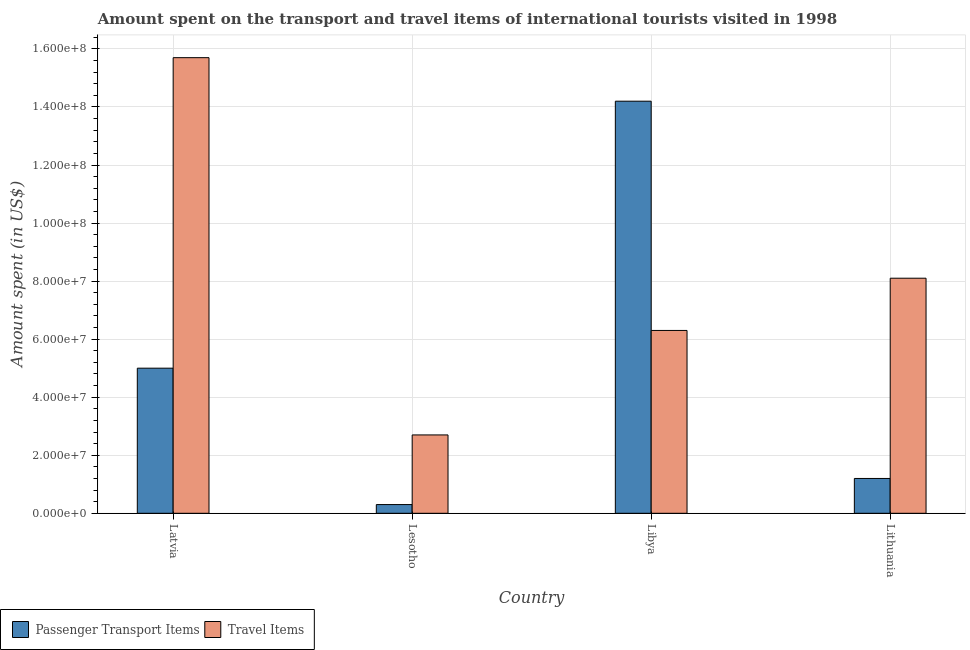How many different coloured bars are there?
Offer a terse response. 2. Are the number of bars per tick equal to the number of legend labels?
Provide a short and direct response. Yes. Are the number of bars on each tick of the X-axis equal?
Make the answer very short. Yes. What is the label of the 2nd group of bars from the left?
Your response must be concise. Lesotho. What is the amount spent on passenger transport items in Lithuania?
Your answer should be compact. 1.20e+07. Across all countries, what is the maximum amount spent on passenger transport items?
Keep it short and to the point. 1.42e+08. Across all countries, what is the minimum amount spent in travel items?
Offer a very short reply. 2.70e+07. In which country was the amount spent in travel items maximum?
Ensure brevity in your answer.  Latvia. In which country was the amount spent in travel items minimum?
Give a very brief answer. Lesotho. What is the total amount spent on passenger transport items in the graph?
Offer a terse response. 2.07e+08. What is the difference between the amount spent on passenger transport items in Latvia and that in Libya?
Your answer should be very brief. -9.20e+07. What is the difference between the amount spent in travel items in Lesotho and the amount spent on passenger transport items in Libya?
Make the answer very short. -1.15e+08. What is the average amount spent in travel items per country?
Provide a short and direct response. 8.20e+07. What is the difference between the amount spent in travel items and amount spent on passenger transport items in Lesotho?
Your answer should be compact. 2.40e+07. In how many countries, is the amount spent in travel items greater than 100000000 US$?
Provide a succinct answer. 1. What is the ratio of the amount spent on passenger transport items in Latvia to that in Lithuania?
Your answer should be very brief. 4.17. Is the amount spent on passenger transport items in Lesotho less than that in Lithuania?
Keep it short and to the point. Yes. What is the difference between the highest and the second highest amount spent on passenger transport items?
Keep it short and to the point. 9.20e+07. What is the difference between the highest and the lowest amount spent on passenger transport items?
Make the answer very short. 1.39e+08. In how many countries, is the amount spent on passenger transport items greater than the average amount spent on passenger transport items taken over all countries?
Your answer should be compact. 1. Is the sum of the amount spent on passenger transport items in Latvia and Lesotho greater than the maximum amount spent in travel items across all countries?
Provide a short and direct response. No. What does the 2nd bar from the left in Libya represents?
Your answer should be very brief. Travel Items. What does the 1st bar from the right in Lithuania represents?
Provide a short and direct response. Travel Items. How many bars are there?
Give a very brief answer. 8. How many countries are there in the graph?
Keep it short and to the point. 4. What is the difference between two consecutive major ticks on the Y-axis?
Make the answer very short. 2.00e+07. Are the values on the major ticks of Y-axis written in scientific E-notation?
Your answer should be very brief. Yes. How many legend labels are there?
Make the answer very short. 2. How are the legend labels stacked?
Provide a succinct answer. Horizontal. What is the title of the graph?
Offer a terse response. Amount spent on the transport and travel items of international tourists visited in 1998. What is the label or title of the X-axis?
Make the answer very short. Country. What is the label or title of the Y-axis?
Keep it short and to the point. Amount spent (in US$). What is the Amount spent (in US$) of Passenger Transport Items in Latvia?
Your answer should be very brief. 5.00e+07. What is the Amount spent (in US$) in Travel Items in Latvia?
Offer a terse response. 1.57e+08. What is the Amount spent (in US$) in Passenger Transport Items in Lesotho?
Ensure brevity in your answer.  3.00e+06. What is the Amount spent (in US$) in Travel Items in Lesotho?
Ensure brevity in your answer.  2.70e+07. What is the Amount spent (in US$) of Passenger Transport Items in Libya?
Give a very brief answer. 1.42e+08. What is the Amount spent (in US$) in Travel Items in Libya?
Keep it short and to the point. 6.30e+07. What is the Amount spent (in US$) of Travel Items in Lithuania?
Ensure brevity in your answer.  8.10e+07. Across all countries, what is the maximum Amount spent (in US$) in Passenger Transport Items?
Your answer should be very brief. 1.42e+08. Across all countries, what is the maximum Amount spent (in US$) in Travel Items?
Your answer should be very brief. 1.57e+08. Across all countries, what is the minimum Amount spent (in US$) in Passenger Transport Items?
Provide a short and direct response. 3.00e+06. Across all countries, what is the minimum Amount spent (in US$) of Travel Items?
Give a very brief answer. 2.70e+07. What is the total Amount spent (in US$) in Passenger Transport Items in the graph?
Your answer should be compact. 2.07e+08. What is the total Amount spent (in US$) in Travel Items in the graph?
Give a very brief answer. 3.28e+08. What is the difference between the Amount spent (in US$) of Passenger Transport Items in Latvia and that in Lesotho?
Your response must be concise. 4.70e+07. What is the difference between the Amount spent (in US$) in Travel Items in Latvia and that in Lesotho?
Provide a succinct answer. 1.30e+08. What is the difference between the Amount spent (in US$) in Passenger Transport Items in Latvia and that in Libya?
Ensure brevity in your answer.  -9.20e+07. What is the difference between the Amount spent (in US$) of Travel Items in Latvia and that in Libya?
Your answer should be very brief. 9.40e+07. What is the difference between the Amount spent (in US$) in Passenger Transport Items in Latvia and that in Lithuania?
Offer a terse response. 3.80e+07. What is the difference between the Amount spent (in US$) of Travel Items in Latvia and that in Lithuania?
Ensure brevity in your answer.  7.60e+07. What is the difference between the Amount spent (in US$) in Passenger Transport Items in Lesotho and that in Libya?
Provide a short and direct response. -1.39e+08. What is the difference between the Amount spent (in US$) in Travel Items in Lesotho and that in Libya?
Your answer should be very brief. -3.60e+07. What is the difference between the Amount spent (in US$) in Passenger Transport Items in Lesotho and that in Lithuania?
Offer a very short reply. -9.00e+06. What is the difference between the Amount spent (in US$) in Travel Items in Lesotho and that in Lithuania?
Your response must be concise. -5.40e+07. What is the difference between the Amount spent (in US$) of Passenger Transport Items in Libya and that in Lithuania?
Ensure brevity in your answer.  1.30e+08. What is the difference between the Amount spent (in US$) in Travel Items in Libya and that in Lithuania?
Your answer should be very brief. -1.80e+07. What is the difference between the Amount spent (in US$) in Passenger Transport Items in Latvia and the Amount spent (in US$) in Travel Items in Lesotho?
Make the answer very short. 2.30e+07. What is the difference between the Amount spent (in US$) of Passenger Transport Items in Latvia and the Amount spent (in US$) of Travel Items in Libya?
Offer a very short reply. -1.30e+07. What is the difference between the Amount spent (in US$) in Passenger Transport Items in Latvia and the Amount spent (in US$) in Travel Items in Lithuania?
Provide a short and direct response. -3.10e+07. What is the difference between the Amount spent (in US$) of Passenger Transport Items in Lesotho and the Amount spent (in US$) of Travel Items in Libya?
Your response must be concise. -6.00e+07. What is the difference between the Amount spent (in US$) of Passenger Transport Items in Lesotho and the Amount spent (in US$) of Travel Items in Lithuania?
Give a very brief answer. -7.80e+07. What is the difference between the Amount spent (in US$) in Passenger Transport Items in Libya and the Amount spent (in US$) in Travel Items in Lithuania?
Your answer should be compact. 6.10e+07. What is the average Amount spent (in US$) of Passenger Transport Items per country?
Keep it short and to the point. 5.18e+07. What is the average Amount spent (in US$) in Travel Items per country?
Ensure brevity in your answer.  8.20e+07. What is the difference between the Amount spent (in US$) in Passenger Transport Items and Amount spent (in US$) in Travel Items in Latvia?
Give a very brief answer. -1.07e+08. What is the difference between the Amount spent (in US$) in Passenger Transport Items and Amount spent (in US$) in Travel Items in Lesotho?
Your response must be concise. -2.40e+07. What is the difference between the Amount spent (in US$) in Passenger Transport Items and Amount spent (in US$) in Travel Items in Libya?
Your answer should be compact. 7.90e+07. What is the difference between the Amount spent (in US$) of Passenger Transport Items and Amount spent (in US$) of Travel Items in Lithuania?
Keep it short and to the point. -6.90e+07. What is the ratio of the Amount spent (in US$) in Passenger Transport Items in Latvia to that in Lesotho?
Provide a succinct answer. 16.67. What is the ratio of the Amount spent (in US$) of Travel Items in Latvia to that in Lesotho?
Provide a succinct answer. 5.81. What is the ratio of the Amount spent (in US$) of Passenger Transport Items in Latvia to that in Libya?
Provide a succinct answer. 0.35. What is the ratio of the Amount spent (in US$) in Travel Items in Latvia to that in Libya?
Provide a succinct answer. 2.49. What is the ratio of the Amount spent (in US$) of Passenger Transport Items in Latvia to that in Lithuania?
Offer a very short reply. 4.17. What is the ratio of the Amount spent (in US$) of Travel Items in Latvia to that in Lithuania?
Give a very brief answer. 1.94. What is the ratio of the Amount spent (in US$) of Passenger Transport Items in Lesotho to that in Libya?
Your response must be concise. 0.02. What is the ratio of the Amount spent (in US$) in Travel Items in Lesotho to that in Libya?
Give a very brief answer. 0.43. What is the ratio of the Amount spent (in US$) in Passenger Transport Items in Libya to that in Lithuania?
Your answer should be very brief. 11.83. What is the ratio of the Amount spent (in US$) of Travel Items in Libya to that in Lithuania?
Offer a terse response. 0.78. What is the difference between the highest and the second highest Amount spent (in US$) in Passenger Transport Items?
Make the answer very short. 9.20e+07. What is the difference between the highest and the second highest Amount spent (in US$) in Travel Items?
Provide a succinct answer. 7.60e+07. What is the difference between the highest and the lowest Amount spent (in US$) in Passenger Transport Items?
Your answer should be compact. 1.39e+08. What is the difference between the highest and the lowest Amount spent (in US$) in Travel Items?
Provide a short and direct response. 1.30e+08. 